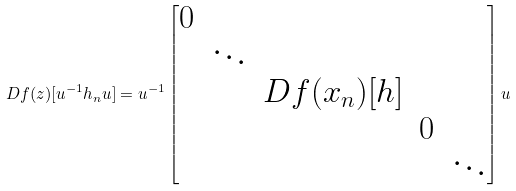<formula> <loc_0><loc_0><loc_500><loc_500>D f ( z ) [ u ^ { - 1 } h _ { n } u ] = u ^ { - 1 } \begin{bmatrix} 0 & & & & \\ & \ddots & & & \\ & & D f ( x _ { n } ) [ h ] & & \\ & & & 0 & \\ & & & & \ddots \end{bmatrix} u</formula> 